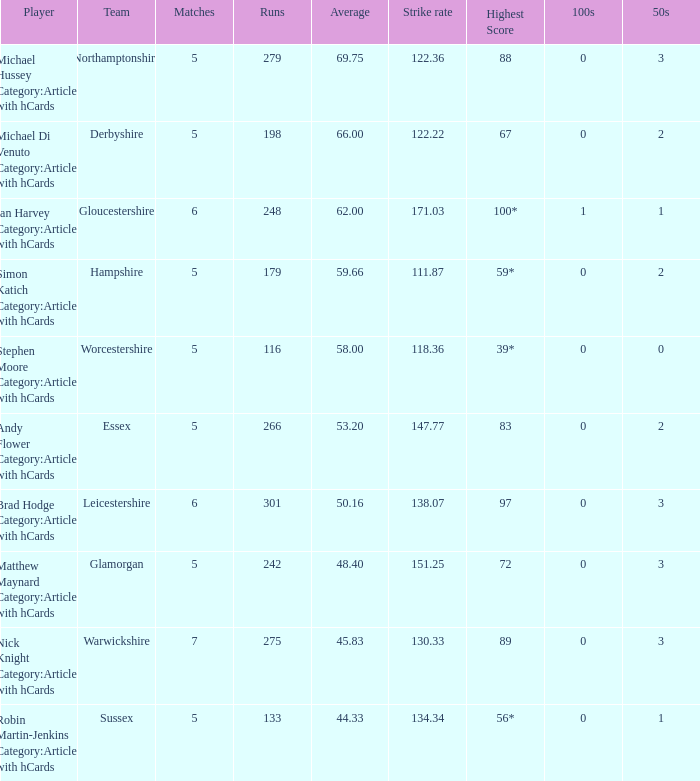If the team is Gloucestershire, what is the average? 62.0. 